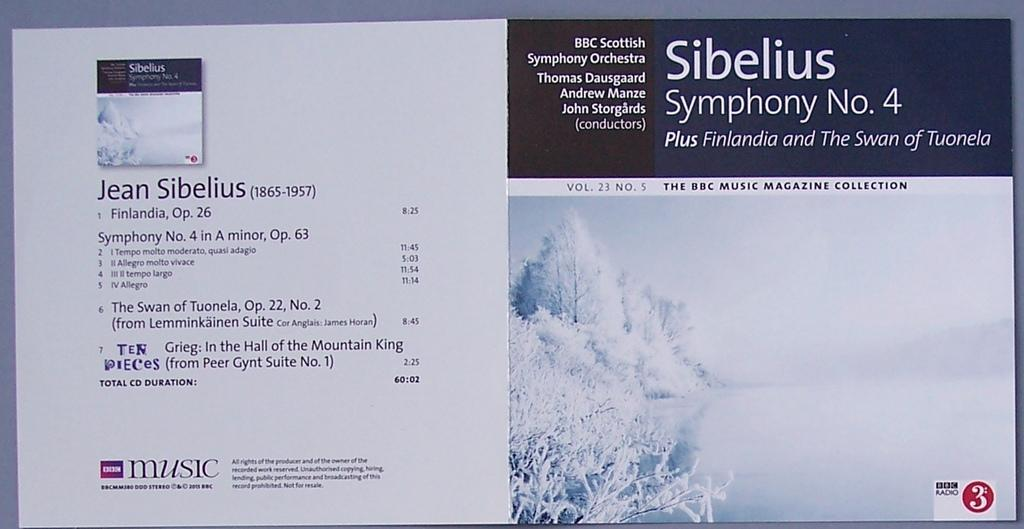What can be found on the left side of the image? There is some text on the left side of the image. What is located on the right side of the image? There are trees on the right side of the image. What is the weather condition in the image? There is snow visible in the image, indicating a cold or wintery setting. What type of visual medium is the image? The image appears to be a poster. What type of question is being asked in the image? There is no question present in the image; it features text, trees, and snow. What material is the copper used for in the image? There is no copper present in the image. 